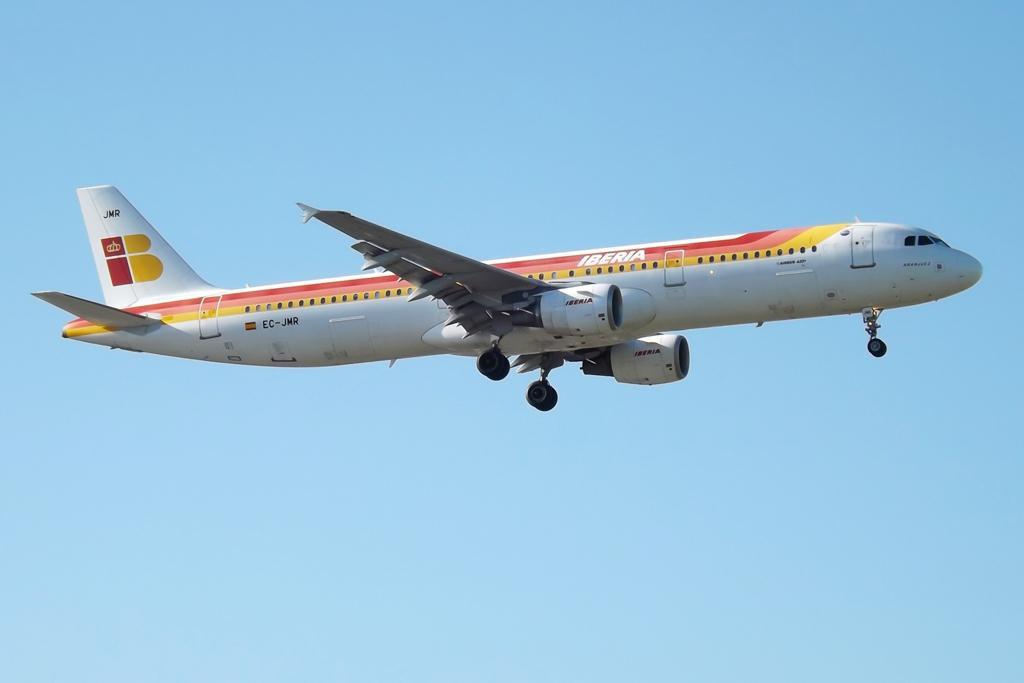What airline does this plane belong to?
Make the answer very short. Iberia. 